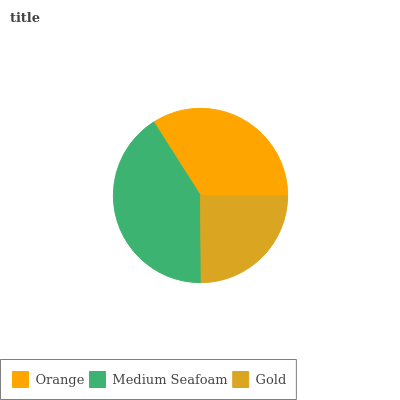Is Gold the minimum?
Answer yes or no. Yes. Is Medium Seafoam the maximum?
Answer yes or no. Yes. Is Medium Seafoam the minimum?
Answer yes or no. No. Is Gold the maximum?
Answer yes or no. No. Is Medium Seafoam greater than Gold?
Answer yes or no. Yes. Is Gold less than Medium Seafoam?
Answer yes or no. Yes. Is Gold greater than Medium Seafoam?
Answer yes or no. No. Is Medium Seafoam less than Gold?
Answer yes or no. No. Is Orange the high median?
Answer yes or no. Yes. Is Orange the low median?
Answer yes or no. Yes. Is Gold the high median?
Answer yes or no. No. Is Medium Seafoam the low median?
Answer yes or no. No. 